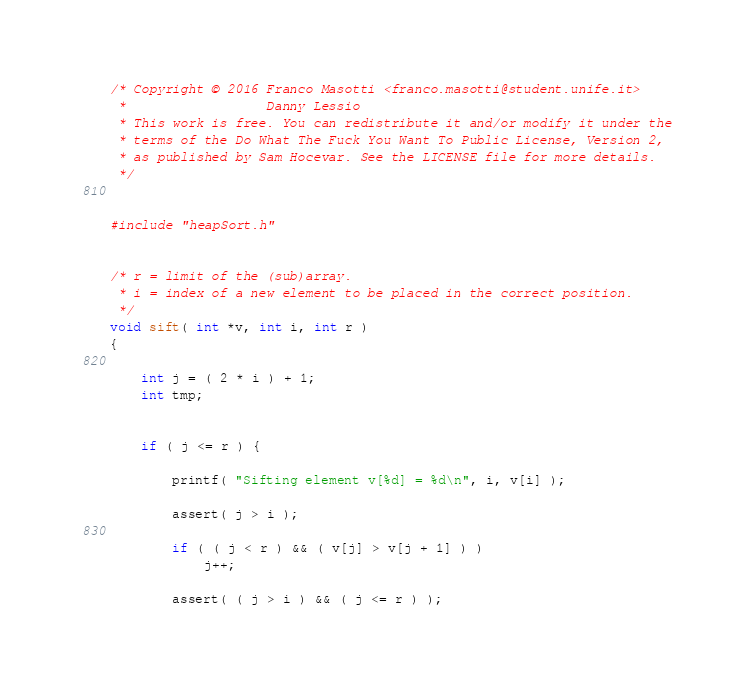Convert code to text. <code><loc_0><loc_0><loc_500><loc_500><_C_>/* Copyright © 2016 Franco Masotti <franco.masotti@student.unife.it>
 *                  Danny Lessio
 * This work is free. You can redistribute it and/or modify it under the
 * terms of the Do What The Fuck You Want To Public License, Version 2,
 * as published by Sam Hocevar. See the LICENSE file for more details.
 */


#include "heapSort.h"


/* r = limit of the (sub)array.
 * i = index of a new element to be placed in the correct position.
 */
void sift( int *v, int i, int r )
{

    int j = ( 2 * i ) + 1;
    int tmp;


    if ( j <= r ) {

        printf( "Sifting element v[%d] = %d\n", i, v[i] );

        assert( j > i );

        if ( ( j < r ) && ( v[j] > v[j + 1] ) )
            j++;

        assert( ( j > i ) && ( j <= r ) );
</code> 